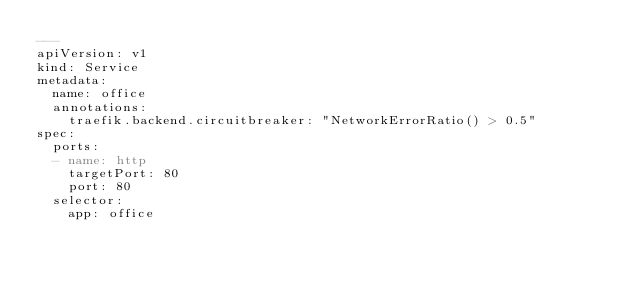<code> <loc_0><loc_0><loc_500><loc_500><_YAML_>---
apiVersion: v1
kind: Service
metadata:
  name: office
  annotations:
    traefik.backend.circuitbreaker: "NetworkErrorRatio() > 0.5"
spec:
  ports:
  - name: http
    targetPort: 80
    port: 80
  selector:
    app: office</code> 